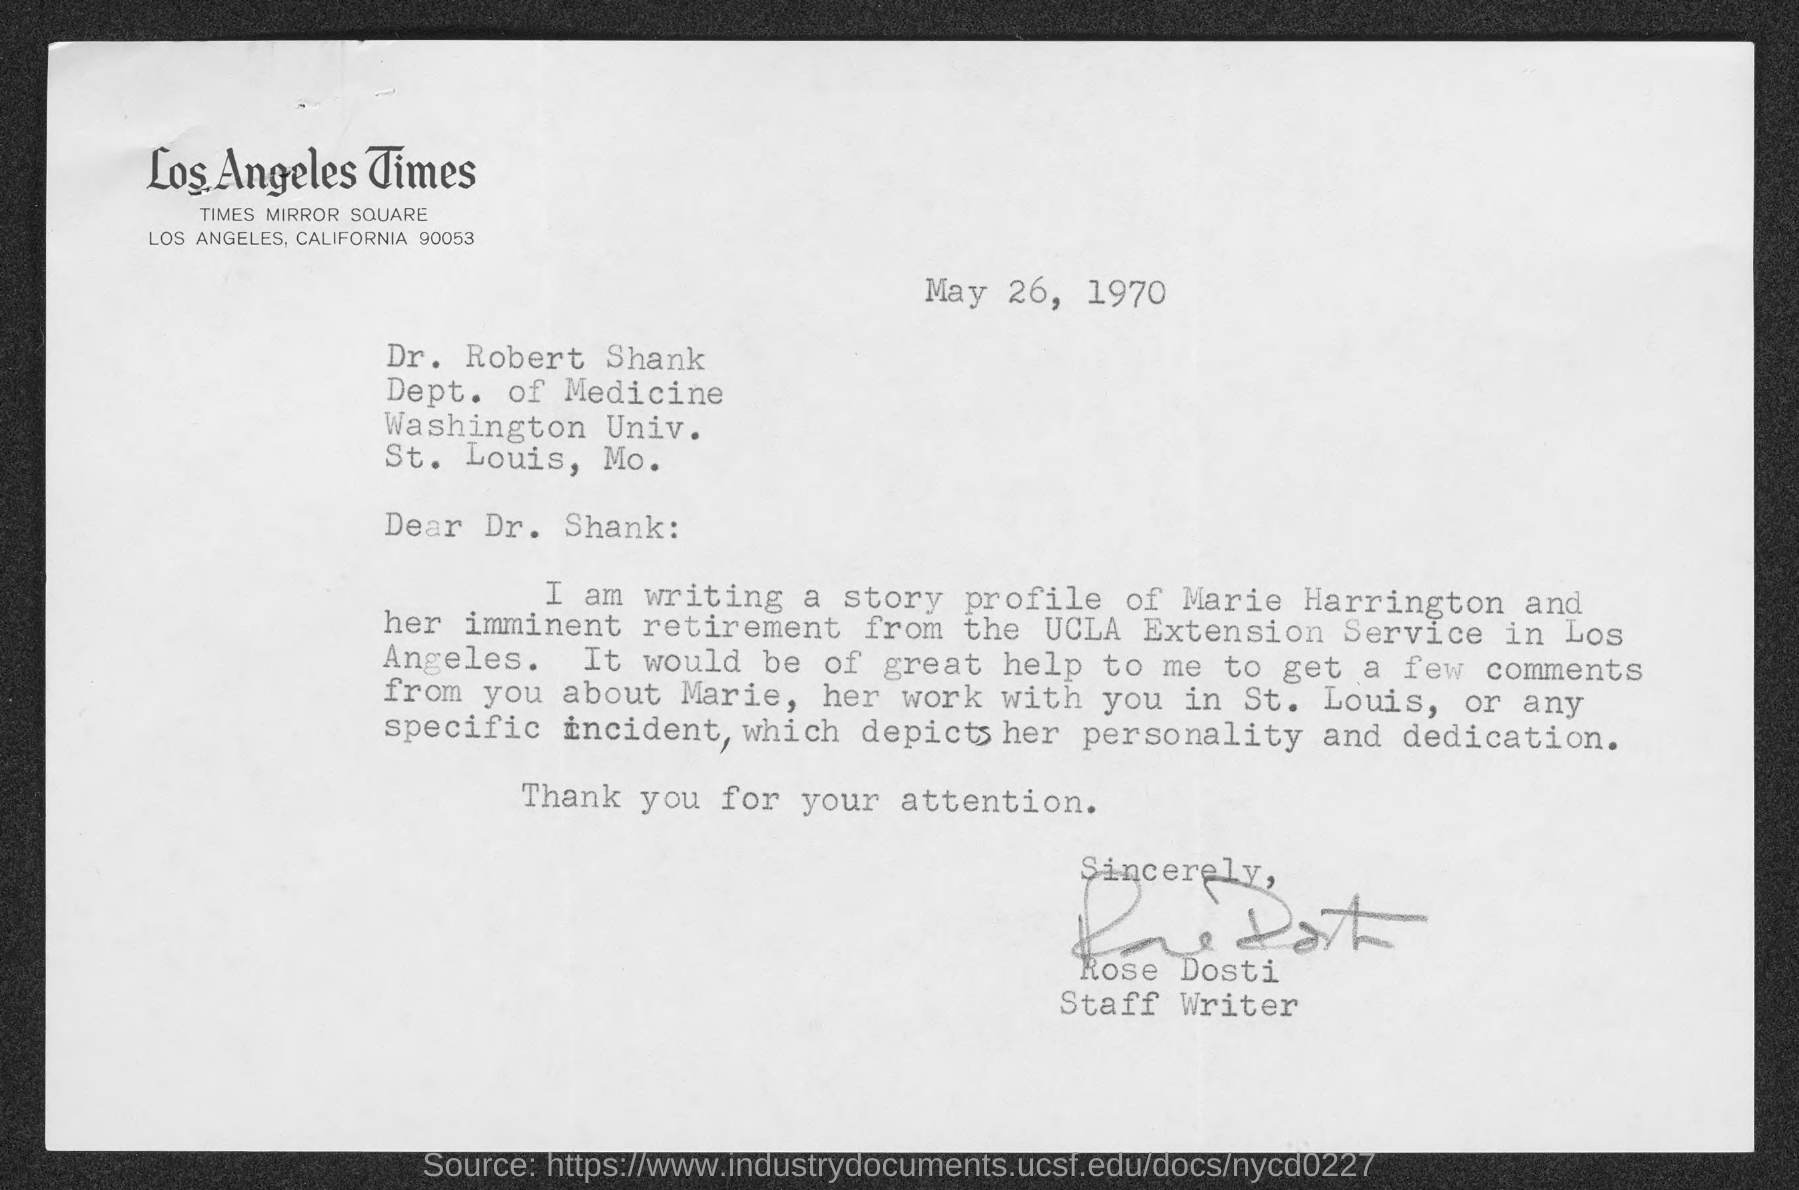What is the date mentioned in this letter?
Your response must be concise. May 26, 1970. Which newspaper is mentioned in the letterhead?
Provide a succinct answer. Los Angeles TImes. Who has signed this letter?
Provide a short and direct response. Rose Dosti. What is the designation of Rose Dosti?
Make the answer very short. Staff Writer. In which department, Dr. Robert Shank works?
Offer a very short reply. Dept. of Medicine. 